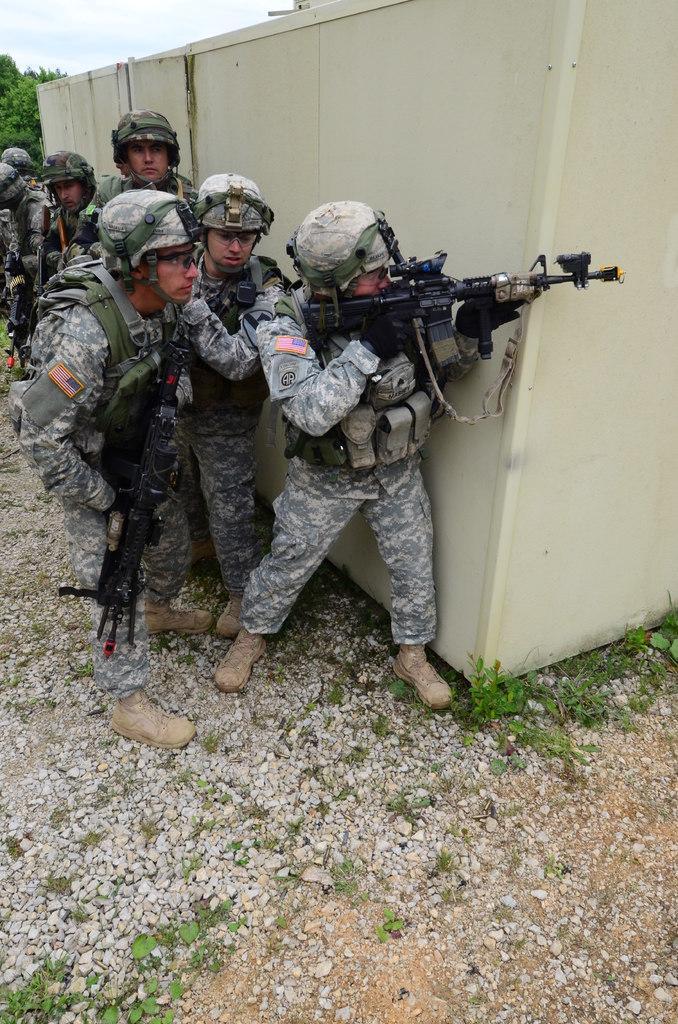Can you describe this image briefly? In the foreground of this image, there are persons holding guns behind a wall. On the bottom, there are small stones and plants on the ground. In the background, there are trees, sky and the cloud. 